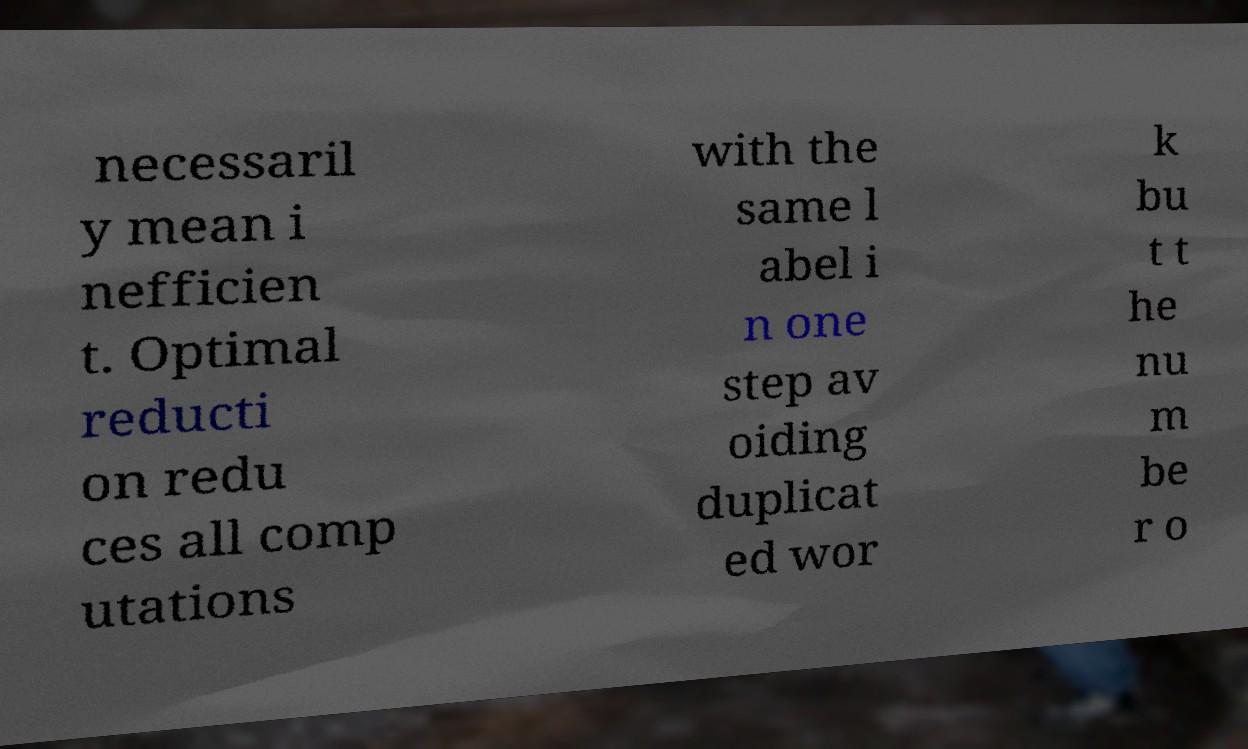There's text embedded in this image that I need extracted. Can you transcribe it verbatim? necessaril y mean i nefficien t. Optimal reducti on redu ces all comp utations with the same l abel i n one step av oiding duplicat ed wor k bu t t he nu m be r o 